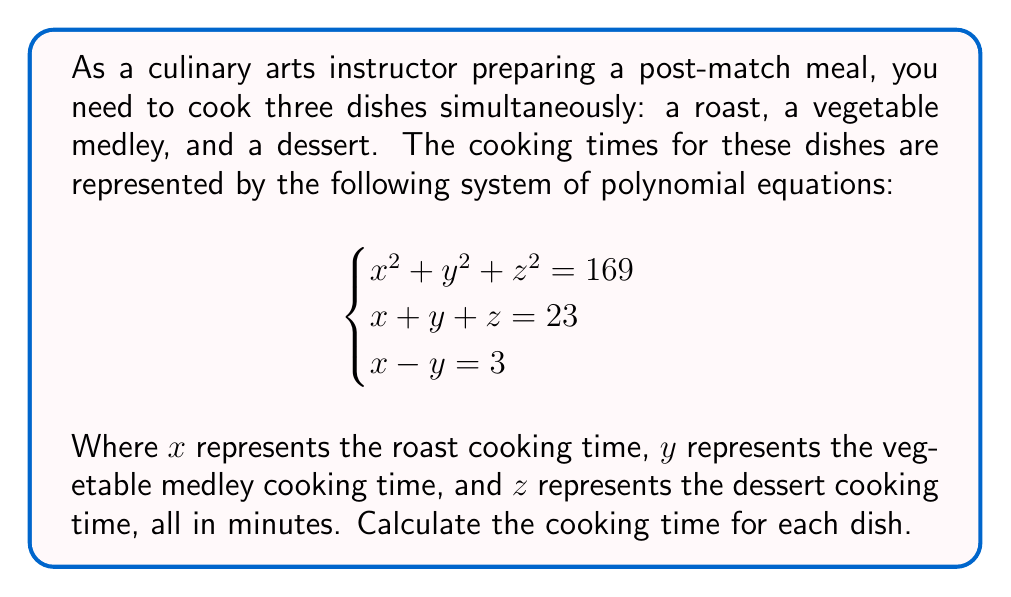Can you answer this question? Let's solve this system of equations step by step:

1) From the third equation, we know that $x = y + 3$. Let's substitute this into the second equation:

   $(y + 3) + y + z = 23$
   $2y + z = 20$

2) Now, let's substitute $x = y + 3$ and $z = 20 - 2y$ into the first equation:

   $(y + 3)^2 + y^2 + (20 - 2y)^2 = 169$

3) Expand this equation:

   $y^2 + 6y + 9 + y^2 + 400 - 80y + 4y^2 = 169$
   $6y^2 - 74y + 240 = 0$

4) Divide everything by 2:

   $3y^2 - 37y + 120 = 0$

5) This is a quadratic equation. We can solve it using the quadratic formula:

   $y = \frac{37 \pm \sqrt{37^2 - 4(3)(120)}}{2(3)}$
   $y = \frac{37 \pm \sqrt{1369 - 1440}}{6}$
   $y = \frac{37 \pm \sqrt{-71}}{6}$

6) Since we're dealing with real cooking times, we can discard the imaginary solution. The only real solution is:

   $y = \frac{37}{6} \approx 6.17$

7) Now we can find $x$ and $z$:

   $x = y + 3 = \frac{37}{6} + 3 = \frac{55}{6} \approx 9.17$
   $z = 23 - x - y = 23 - \frac{55}{6} - \frac{37}{6} = \frac{46}{6} \approx 7.67$

Therefore, the cooking times are approximately:
Roast ($x$): 9.17 minutes
Vegetable medley ($y$): 6.17 minutes
Dessert ($z$): 7.67 minutes
Answer: $x = \frac{55}{6}$, $y = \frac{37}{6}$, $z = \frac{46}{6}$ 